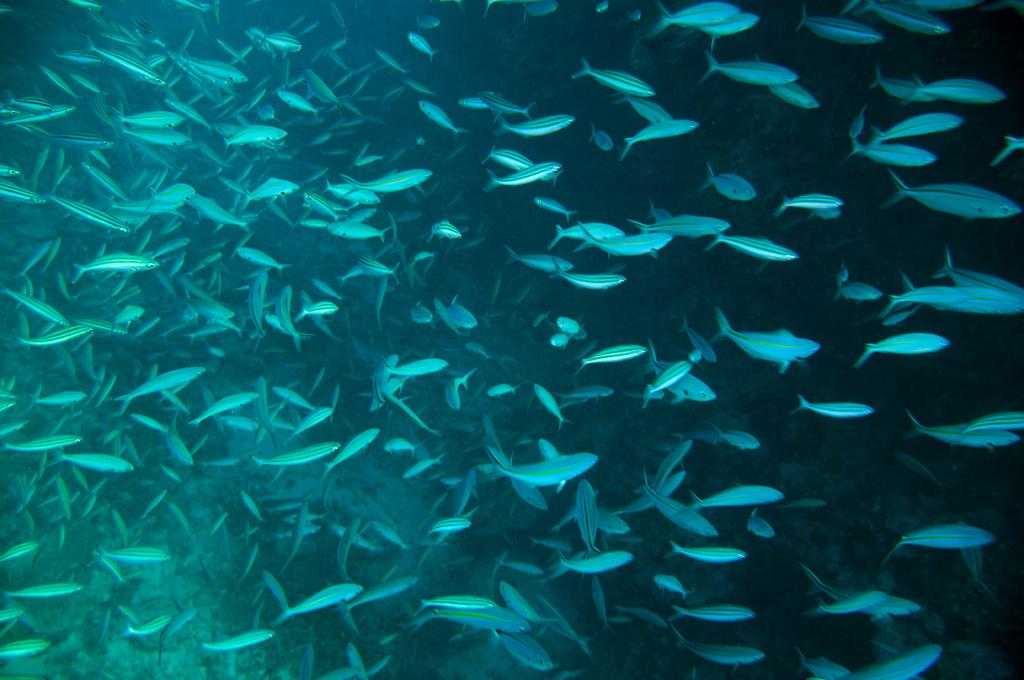What type of animals can be seen in the image? There are fishes in the image. Where are the fishes located? The fishes are in the water. What type of hall can be seen in the image? There is no hall present in the image; it features fishes in the water. What type of harbor is visible in the image? There is no harbor present in the image; it features fishes in the water. 